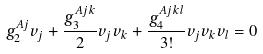Convert formula to latex. <formula><loc_0><loc_0><loc_500><loc_500>g _ { 2 } ^ { A j } v _ { j } + \frac { g _ { 3 } ^ { A j k } } { 2 } v _ { j } v _ { k } + \frac { g _ { 4 } ^ { A j k l } } { 3 ! } v _ { j } v _ { k } v _ { l } = 0</formula> 